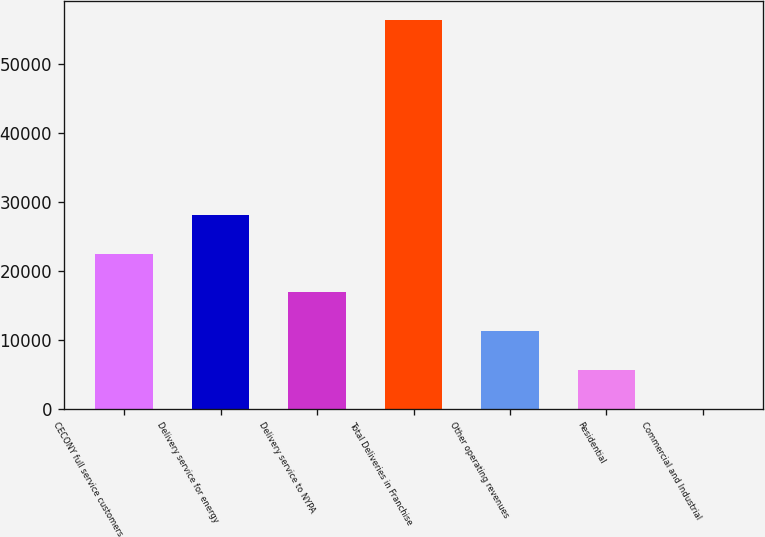Convert chart to OTSL. <chart><loc_0><loc_0><loc_500><loc_500><bar_chart><fcel>CECONY full service customers<fcel>Delivery service for energy<fcel>Delivery service to NYPA<fcel>Total Deliveries in Franchise<fcel>Other operating revenues<fcel>Residential<fcel>Commercial and Industrial<nl><fcel>22534.5<fcel>28162.5<fcel>16906.4<fcel>56303<fcel>11278.3<fcel>5650.19<fcel>22.1<nl></chart> 